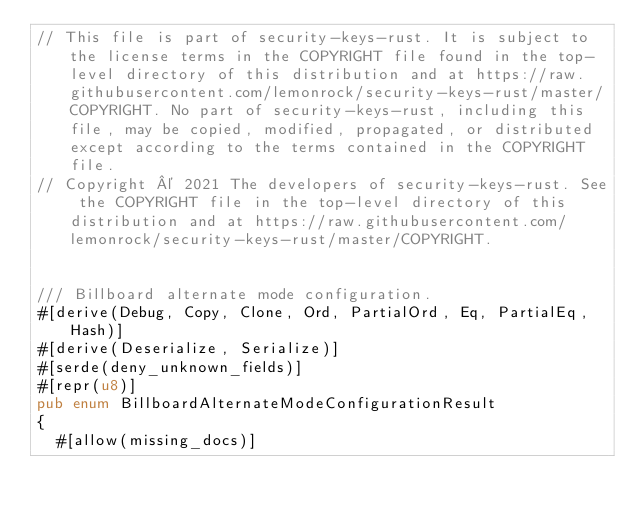<code> <loc_0><loc_0><loc_500><loc_500><_Rust_>// This file is part of security-keys-rust. It is subject to the license terms in the COPYRIGHT file found in the top-level directory of this distribution and at https://raw.githubusercontent.com/lemonrock/security-keys-rust/master/COPYRIGHT. No part of security-keys-rust, including this file, may be copied, modified, propagated, or distributed except according to the terms contained in the COPYRIGHT file.
// Copyright © 2021 The developers of security-keys-rust. See the COPYRIGHT file in the top-level directory of this distribution and at https://raw.githubusercontent.com/lemonrock/security-keys-rust/master/COPYRIGHT.


/// Billboard alternate mode configuration.
#[derive(Debug, Copy, Clone, Ord, PartialOrd, Eq, PartialEq, Hash)]
#[derive(Deserialize, Serialize)]
#[serde(deny_unknown_fields)]
#[repr(u8)]
pub enum BillboardAlternateModeConfigurationResult
{
	#[allow(missing_docs)]</code> 